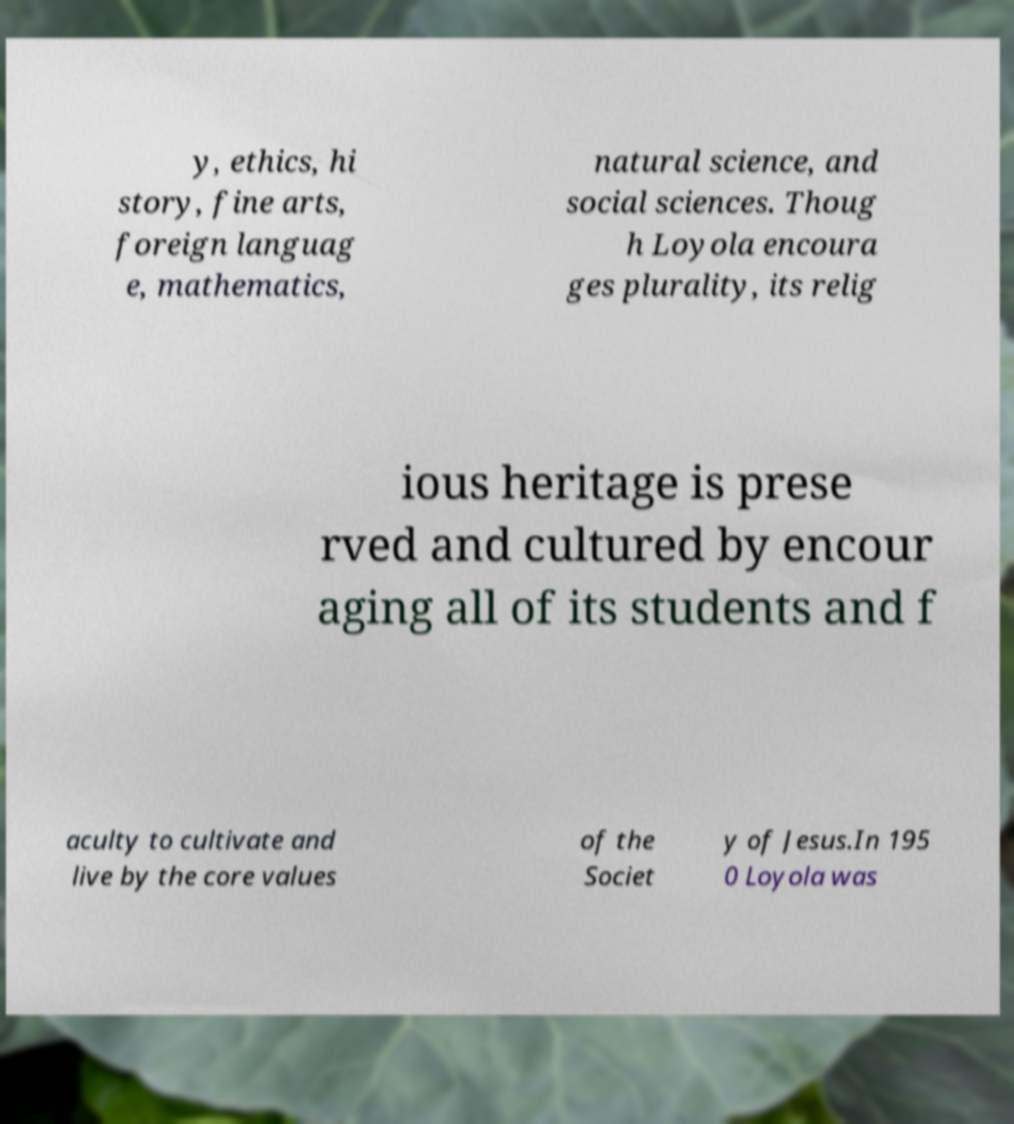I need the written content from this picture converted into text. Can you do that? y, ethics, hi story, fine arts, foreign languag e, mathematics, natural science, and social sciences. Thoug h Loyola encoura ges plurality, its relig ious heritage is prese rved and cultured by encour aging all of its students and f aculty to cultivate and live by the core values of the Societ y of Jesus.In 195 0 Loyola was 